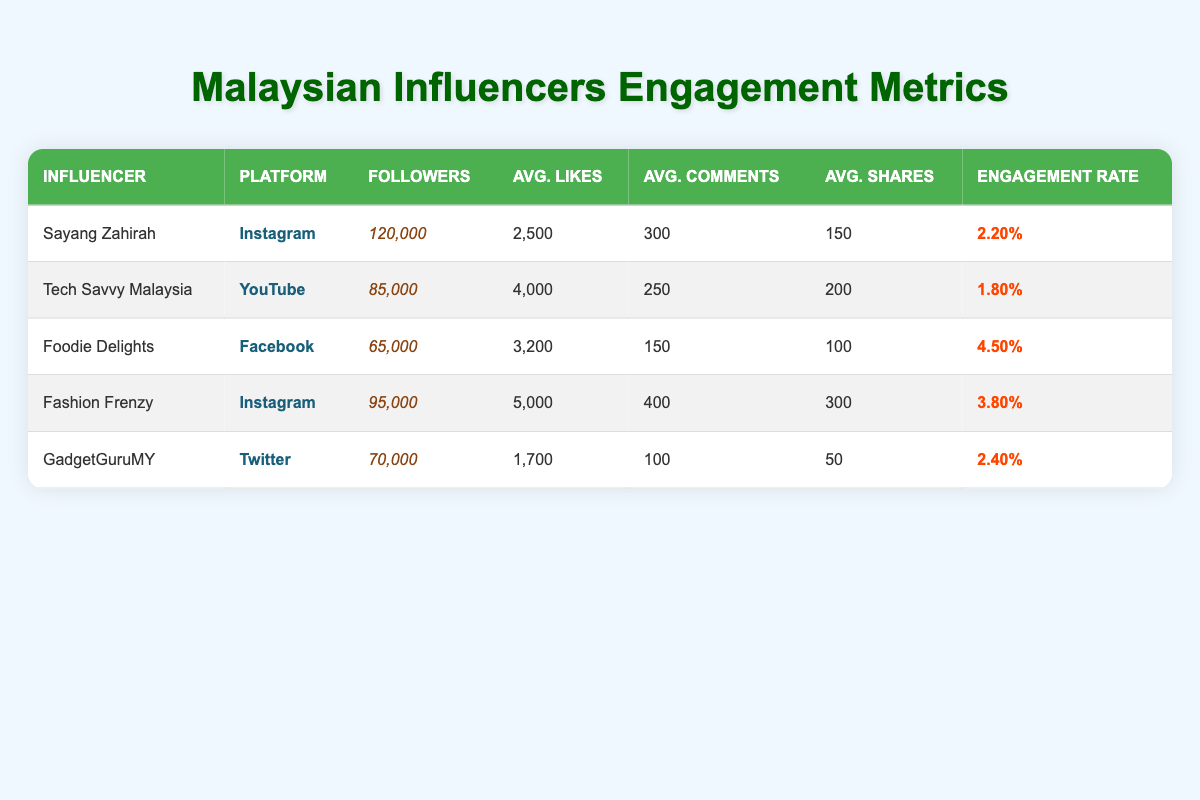What is the engagement rate of Foodie Delights? The engagement rate value is listed directly in the table under the "Engagement Rate" column for Foodie Delights, which is 0.045 or 4.50%.
Answer: 4.50% Which influencer has the highest average likes? By comparing the average likes for each influencer in the table, Fashion Frenzy has the highest average likes at 5000.
Answer: Fashion Frenzy What is the total number of followers for influencers on Instagram? Sayang Zahirah has 120,000 followers and Fashion Frenzy has 95,000 followers on Instagram. Adding those gives a total of 120,000 + 95,000 = 215,000 followers.
Answer: 215,000 Is the engagement rate of GadgetGuruMY greater than that of Tech Savvy Malaysia? GadgetGuruMY has an engagement rate of 0.024 (2.40%) while Tech Savvy Malaysia has an engagement rate of 0.018 (1.80%). Since 0.024 is greater than 0.018, the statement is true.
Answer: Yes What is the average engagement rate for all influencers? To calculate the average engagement rate, add the engagement rates: 0.022 + 0.018 + 0.045 + 0.038 + 0.024 = 0.147, then divide by 5 (the number of influencers), giving 0.147 / 5 = 0.0294 or 2.94%.
Answer: 2.94% Which platform has the lowest average comments? By reviewing the "Avg. Comments" column, Foodie Delights has the lowest average comments at 150.
Answer: Facebook How many more average shares does Fashion Frenzy have compared to GadgetGuruMY? Fashion Frenzy has an average of 300 shares, while GadgetGuruMY has 50. The difference is 300 - 50 = 250 shares.
Answer: 250 shares Is there any influencer with over 100,000 followers? By examining the "Followers" column, only Sayang Zahirah exceeds 100,000 followers with 120,000. Therefore, the answer is yes.
Answer: Yes 